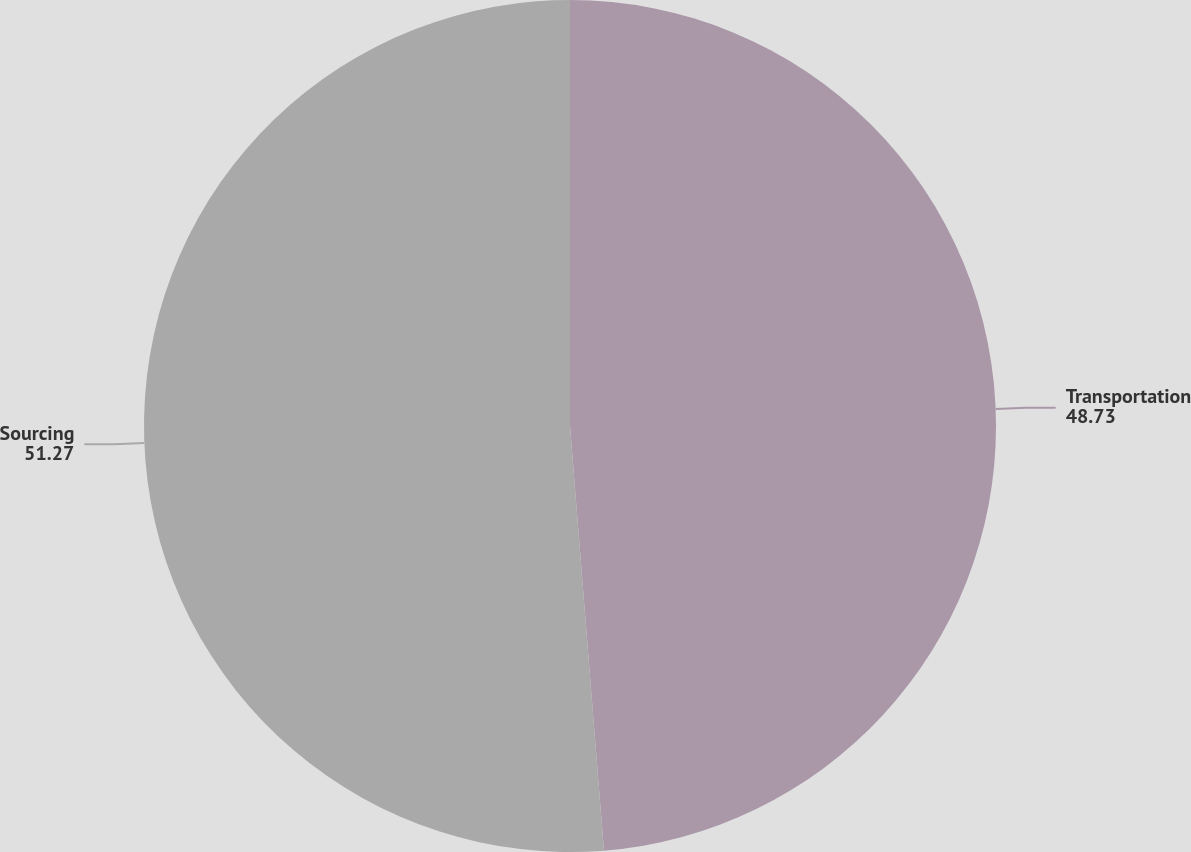Convert chart to OTSL. <chart><loc_0><loc_0><loc_500><loc_500><pie_chart><fcel>Transportation<fcel>Sourcing<nl><fcel>48.73%<fcel>51.27%<nl></chart> 